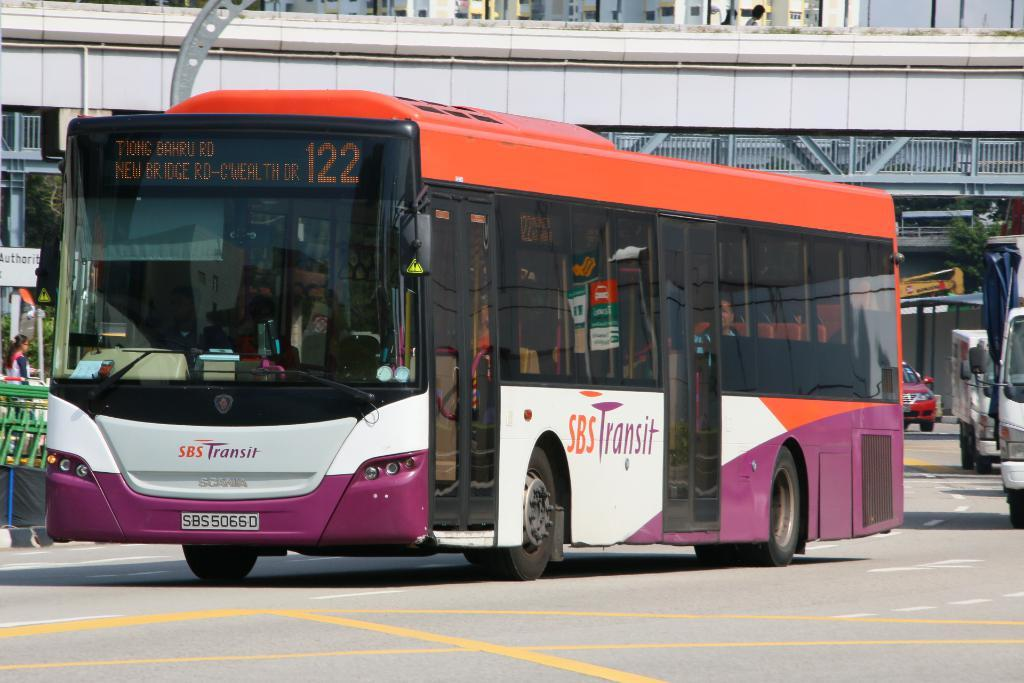<image>
Provide a brief description of the given image. A SBS Transit bus has a number of 122. 